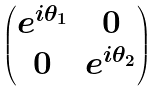<formula> <loc_0><loc_0><loc_500><loc_500>\begin{pmatrix} e ^ { i \theta _ { 1 } } & 0 \\ 0 & e ^ { i \theta _ { 2 } } \end{pmatrix}</formula> 